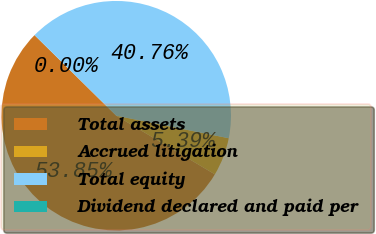Convert chart to OTSL. <chart><loc_0><loc_0><loc_500><loc_500><pie_chart><fcel>Total assets<fcel>Accrued litigation<fcel>Total equity<fcel>Dividend declared and paid per<nl><fcel>53.85%<fcel>5.39%<fcel>40.76%<fcel>0.0%<nl></chart> 